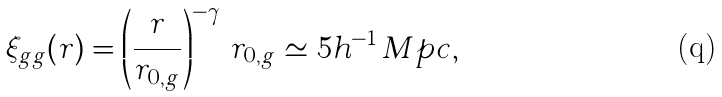Convert formula to latex. <formula><loc_0><loc_0><loc_500><loc_500>\xi _ { g g } ( r ) = \left ( \frac { r } { r _ { 0 , g } } \right ) ^ { - \gamma } \, r _ { 0 , g } \simeq 5 h ^ { - 1 } \, M p c ,</formula> 